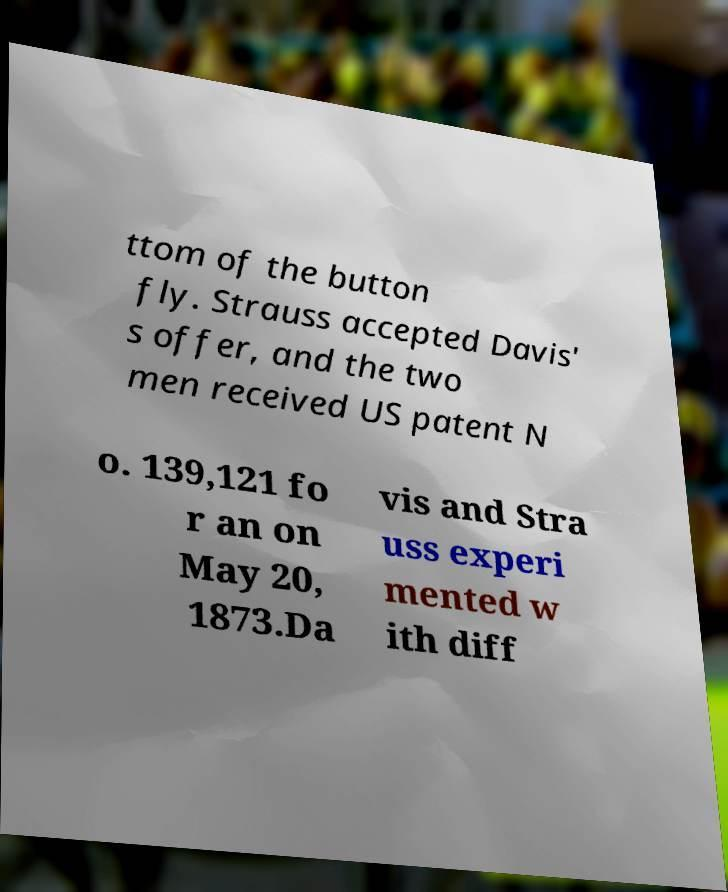I need the written content from this picture converted into text. Can you do that? ttom of the button fly. Strauss accepted Davis' s offer, and the two men received US patent N o. 139,121 fo r an on May 20, 1873.Da vis and Stra uss experi mented w ith diff 